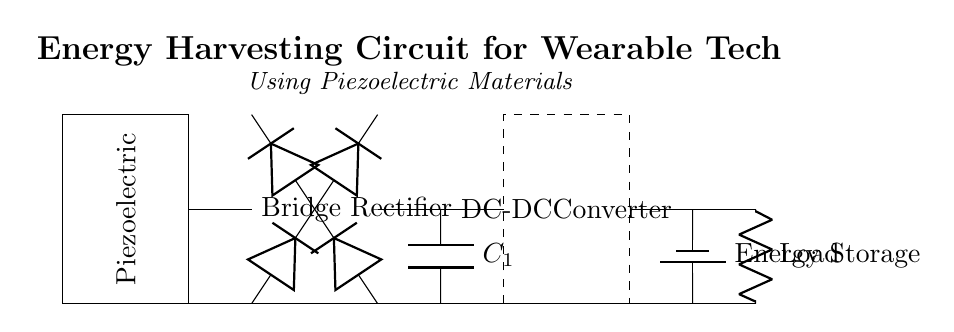What type of energy source does this circuit utilize? The circuit uses piezoelectric materials as the energy source, which generate electricity when mechanically stressed.
Answer: piezoelectric materials What is the purpose of the bridge rectifier in this circuit? The bridge rectifier converts alternating current generated by the piezoelectric element into direct current suitable for charging the energy storage component.
Answer: convert AC to DC How many capacitors are present in this circuit? There is one capacitor labeled C1 that smooths the output from the bridge rectifier before it reaches the DC-DC converter.
Answer: one What is the role of the DC-DC converter in this circuit? The DC-DC converter adjusts the voltage to a desired level for efficient use in powering the load, ensuring the output voltage is stable despite varying input.
Answer: voltage adjustment What component is used for energy storage? The energy storage component in this circuit is represented by a battery, which stores the energy harvested from the piezoelectric materials for later use.
Answer: battery What type of load is connected at the output of this circuit? The load is indicated by a resistor in the circuit, which represents any device that consumes the electrical energy stored and converted in the previous stages.
Answer: resistor Why is a smoothing capacitor necessary in this circuit? The smoothing capacitor eliminates voltage fluctuations caused by the pulsating DC coming from the bridge rectifier, providing a steadier voltage to the DC-DC converter and load.
Answer: to eliminate voltage fluctuations 